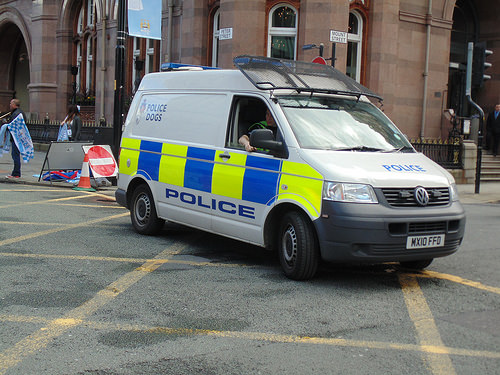<image>
Is the car next to the building? Yes. The car is positioned adjacent to the building, located nearby in the same general area. Where is the sign in relation to the van? Is it in front of the van? No. The sign is not in front of the van. The spatial positioning shows a different relationship between these objects. 